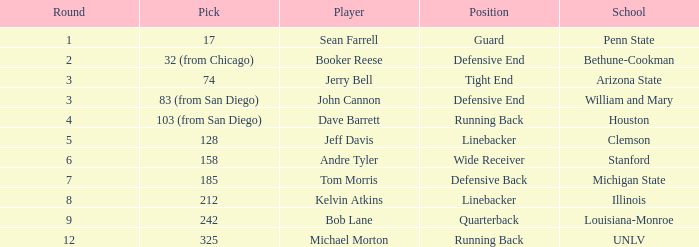What pick did Clemson choose? 128.0. Give me the full table as a dictionary. {'header': ['Round', 'Pick', 'Player', 'Position', 'School'], 'rows': [['1', '17', 'Sean Farrell', 'Guard', 'Penn State'], ['2', '32 (from Chicago)', 'Booker Reese', 'Defensive End', 'Bethune-Cookman'], ['3', '74', 'Jerry Bell', 'Tight End', 'Arizona State'], ['3', '83 (from San Diego)', 'John Cannon', 'Defensive End', 'William and Mary'], ['4', '103 (from San Diego)', 'Dave Barrett', 'Running Back', 'Houston'], ['5', '128', 'Jeff Davis', 'Linebacker', 'Clemson'], ['6', '158', 'Andre Tyler', 'Wide Receiver', 'Stanford'], ['7', '185', 'Tom Morris', 'Defensive Back', 'Michigan State'], ['8', '212', 'Kelvin Atkins', 'Linebacker', 'Illinois'], ['9', '242', 'Bob Lane', 'Quarterback', 'Louisiana-Monroe'], ['12', '325', 'Michael Morton', 'Running Back', 'UNLV']]} 